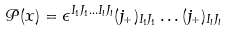Convert formula to latex. <formula><loc_0><loc_0><loc_500><loc_500>\mathcal { P } ( x ) = \epsilon ^ { I _ { 1 } J _ { 1 } \dots I _ { l } J _ { l } } ( j _ { + } ) _ { I _ { 1 } J _ { 1 } } \dots ( j _ { + } ) _ { I _ { l } J _ { l } }</formula> 